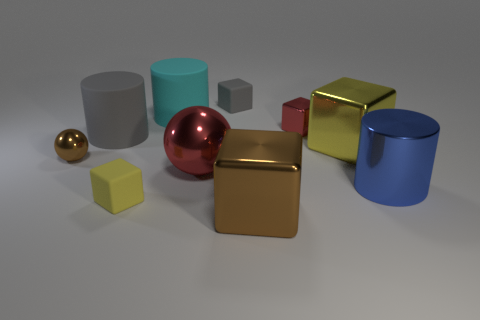Subtract all brown blocks. How many blocks are left? 4 Subtract 1 cubes. How many cubes are left? 4 Subtract all brown shiny cubes. How many cubes are left? 4 Subtract all blue cubes. Subtract all gray spheres. How many cubes are left? 5 Subtract all cylinders. How many objects are left? 7 Subtract all purple blocks. Subtract all big matte objects. How many objects are left? 8 Add 1 large gray objects. How many large gray objects are left? 2 Add 1 small metal blocks. How many small metal blocks exist? 2 Subtract 1 red spheres. How many objects are left? 9 